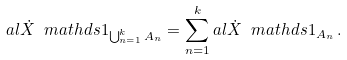<formula> <loc_0><loc_0><loc_500><loc_500>a l { \dot { X } } { \ m a t h d s 1 _ { \bigcup _ { n = 1 } ^ { k } A _ { n } } } = \sum _ { n = 1 } ^ { k } a l { \dot { X } } { \ m a t h d s 1 _ { A _ { n } } } \, .</formula> 